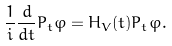<formula> <loc_0><loc_0><loc_500><loc_500>\frac { 1 } { i } \frac { d } { d t } P _ { t } \varphi = H _ { V } ( t ) P _ { t } \varphi .</formula> 